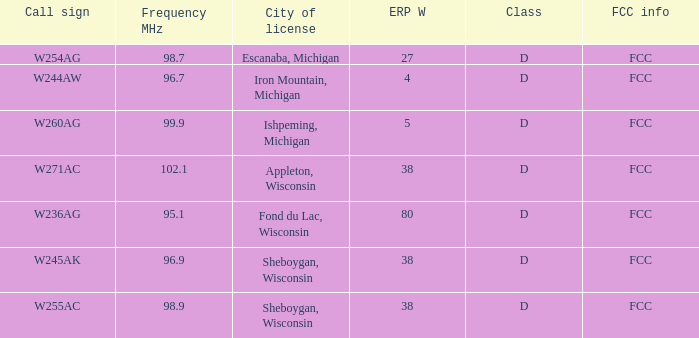What was the class for Appleton, Wisconsin? D. 